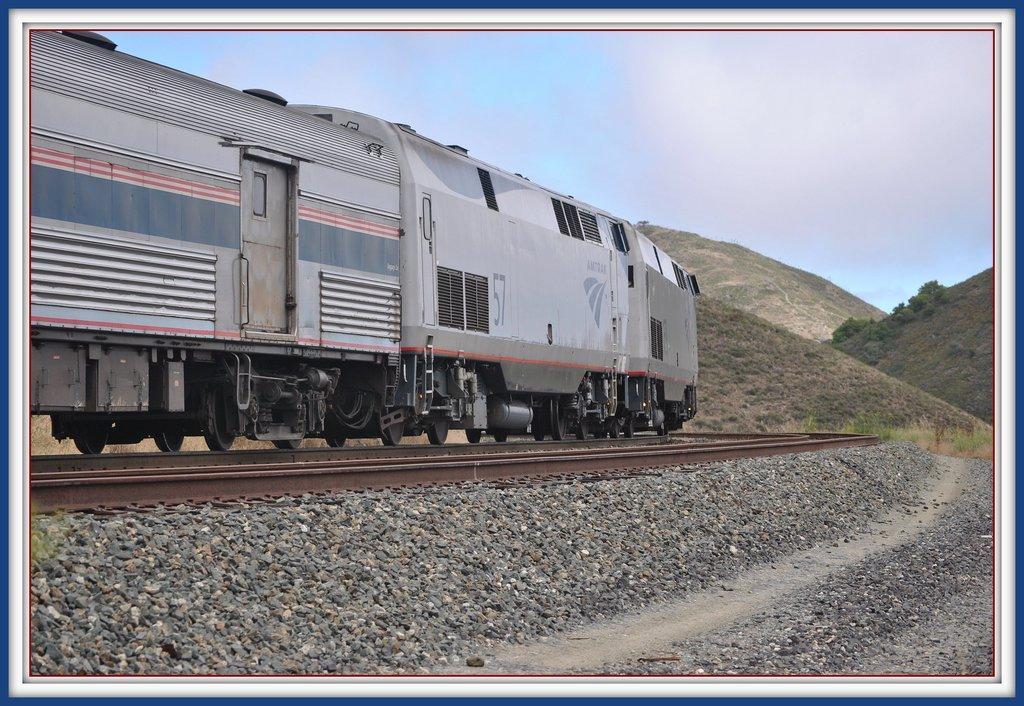Could you give a brief overview of what you see in this image? This looks like an edited image. I can see the train moving on the rail track. These are the rocks. I can see the hills with plants and trees. 